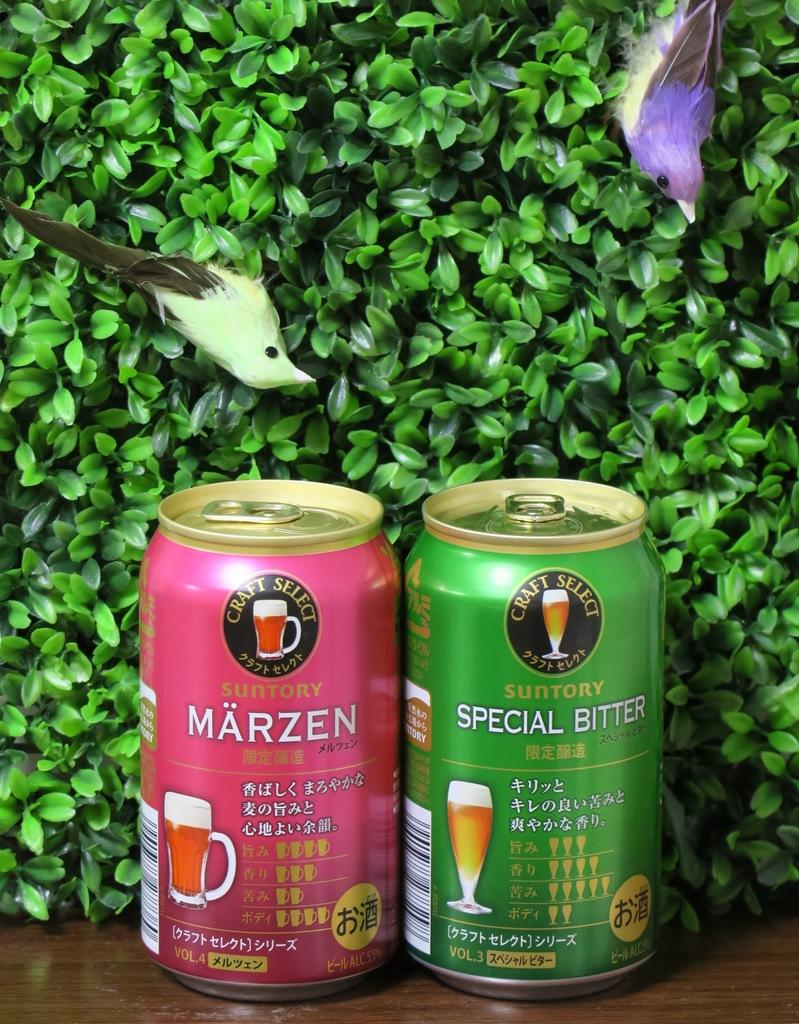<image>
Present a compact description of the photo's key features. Two beer cans that say Craft Select are in front of a bush with two fake birds in it. 